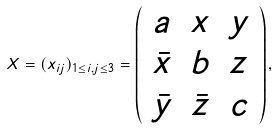<formula> <loc_0><loc_0><loc_500><loc_500>X = ( x _ { i j } ) _ { 1 \leq i , j \leq 3 } = \left ( \begin{array} { c c c } a & x & y \\ \bar { x } & b & z \\ \bar { y } & \bar { z } & c \end{array} \right ) ,</formula> 